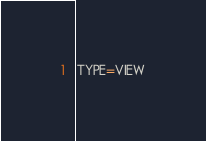<code> <loc_0><loc_0><loc_500><loc_500><_VisualBasic_>TYPE=VIEW</code> 